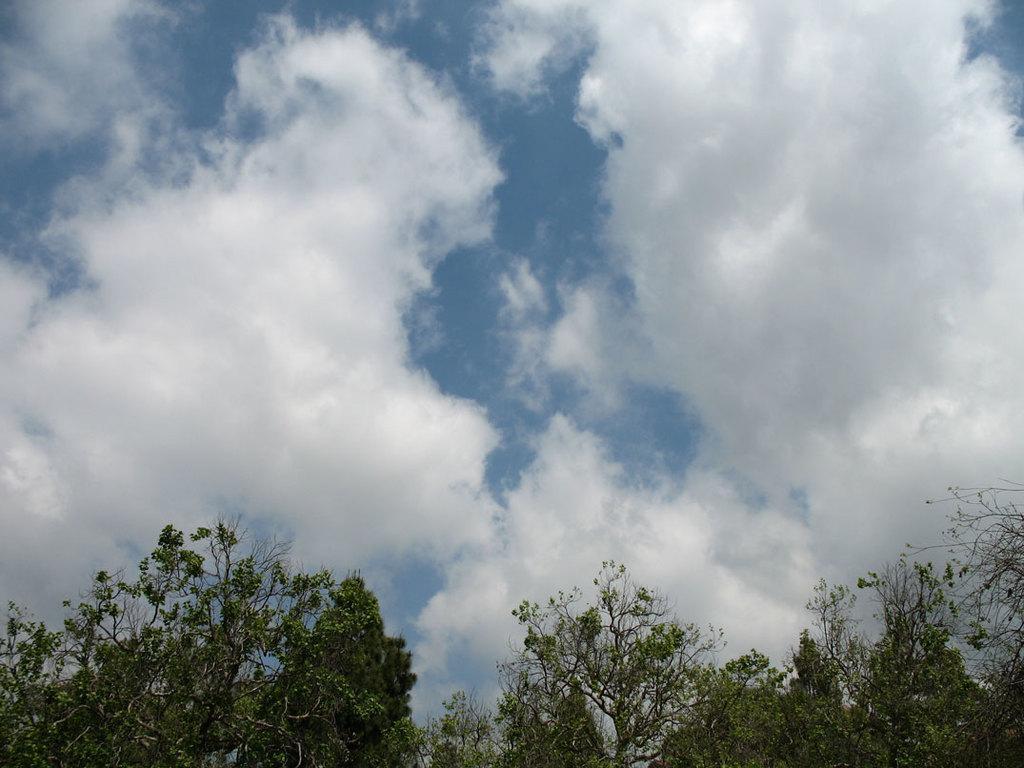How would you summarize this image in a sentence or two? There are trees having green color leaves. In the background, there are clouds in the sky. 